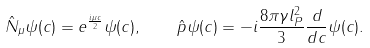Convert formula to latex. <formula><loc_0><loc_0><loc_500><loc_500>\hat { N } _ { \mu } \psi ( c ) = e ^ { \frac { i \mu c } { 2 } } \psi ( c ) , \quad \hat { p } \psi ( c ) = - i \frac { 8 \pi \gamma l _ { P } ^ { 2 } } { 3 } \frac { d } { d c } \psi ( c ) .</formula> 